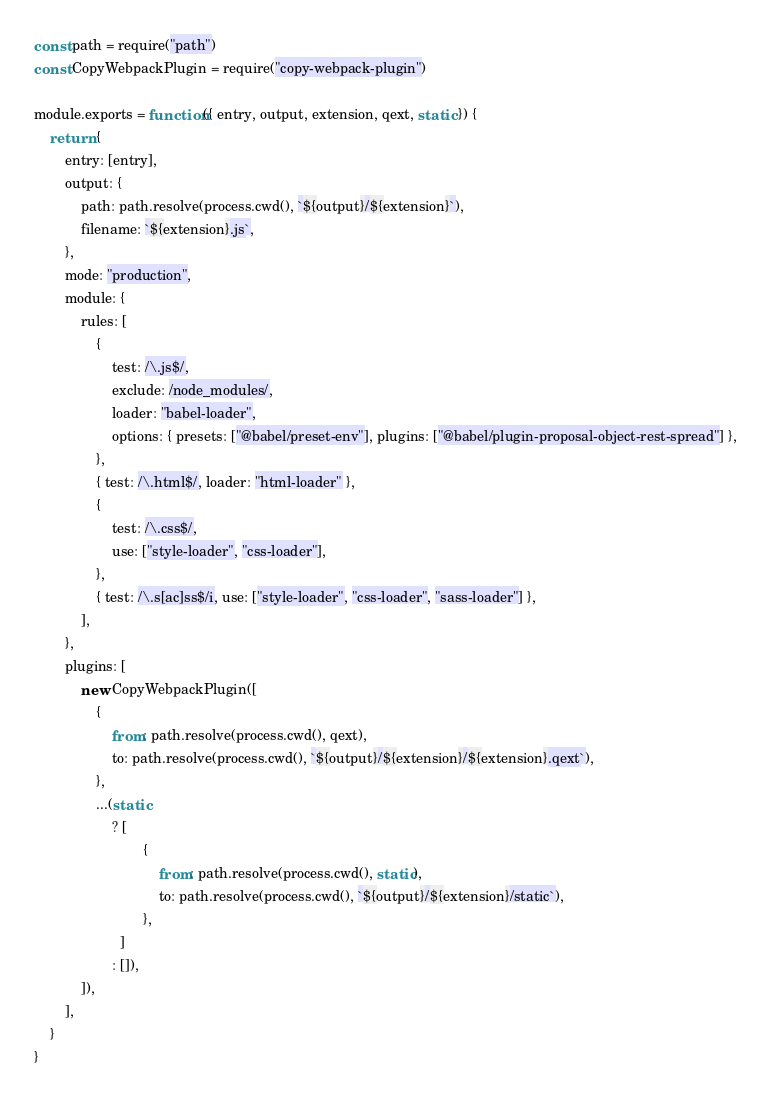Convert code to text. <code><loc_0><loc_0><loc_500><loc_500><_JavaScript_>const path = require("path")
const CopyWebpackPlugin = require("copy-webpack-plugin")

module.exports = function({ entry, output, extension, qext, static }) {
	return {
		entry: [entry],
		output: {
			path: path.resolve(process.cwd(), `${output}/${extension}`),
			filename: `${extension}.js`,
		},
		mode: "production",
		module: {
			rules: [
				{
					test: /\.js$/,
					exclude: /node_modules/,
					loader: "babel-loader",
					options: { presets: ["@babel/preset-env"], plugins: ["@babel/plugin-proposal-object-rest-spread"] },
				},
				{ test: /\.html$/, loader: "html-loader" },
				{
					test: /\.css$/,
					use: ["style-loader", "css-loader"],
				},
				{ test: /\.s[ac]ss$/i, use: ["style-loader", "css-loader", "sass-loader"] },
			],
		},
		plugins: [
			new CopyWebpackPlugin([
				{
					from: path.resolve(process.cwd(), qext),
					to: path.resolve(process.cwd(), `${output}/${extension}/${extension}.qext`),
				},
				...(static
					? [
							{
								from: path.resolve(process.cwd(), static),
								to: path.resolve(process.cwd(), `${output}/${extension}/static`),
							},
					  ]
					: []),
			]),
		],
	}
}
</code> 